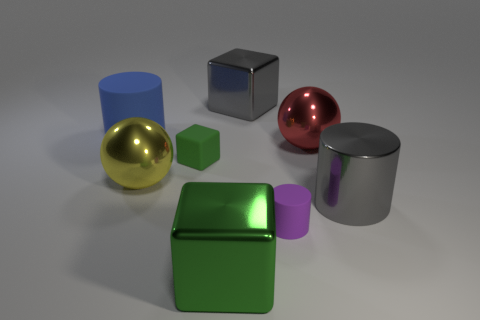Add 2 green matte objects. How many objects exist? 10 Subtract all cylinders. How many objects are left? 5 Add 1 big gray shiny things. How many big gray shiny things are left? 3 Add 6 small metallic things. How many small metallic things exist? 6 Subtract 2 green blocks. How many objects are left? 6 Subtract all big yellow metallic objects. Subtract all big metallic cylinders. How many objects are left? 6 